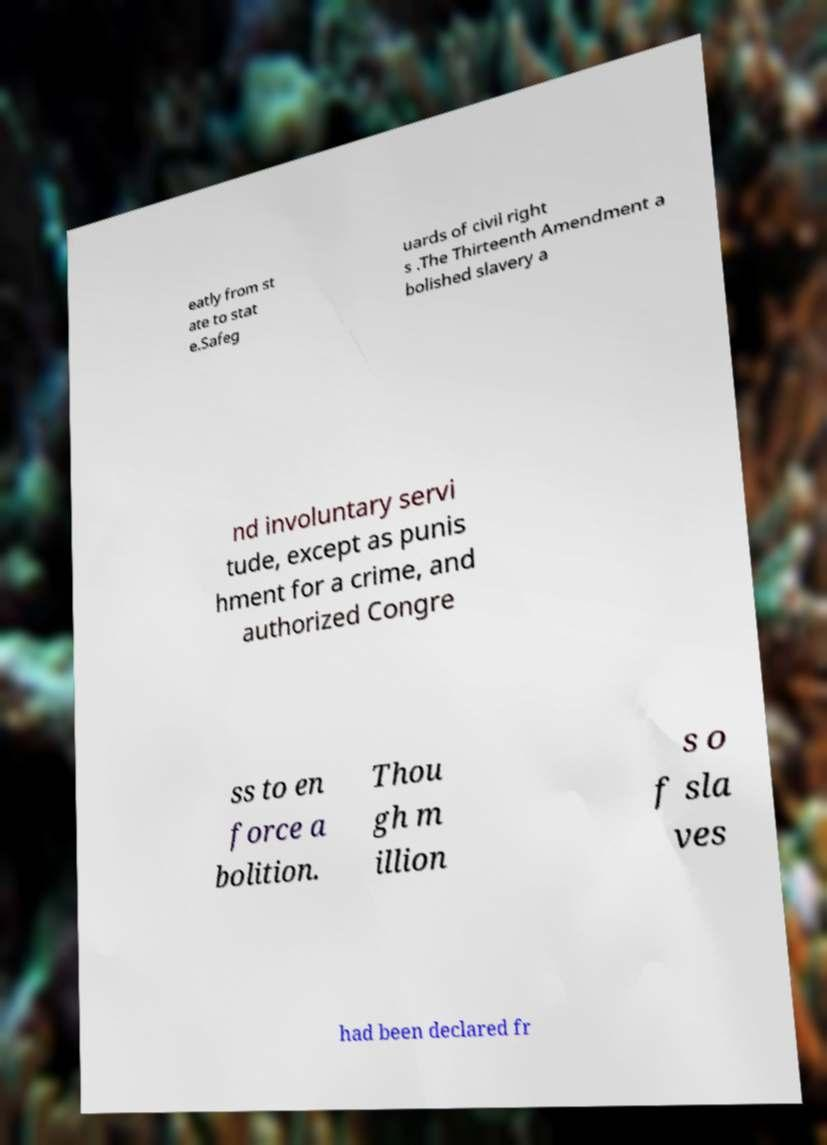Please identify and transcribe the text found in this image. eatly from st ate to stat e.Safeg uards of civil right s .The Thirteenth Amendment a bolished slavery a nd involuntary servi tude, except as punis hment for a crime, and authorized Congre ss to en force a bolition. Thou gh m illion s o f sla ves had been declared fr 